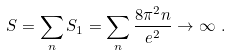<formula> <loc_0><loc_0><loc_500><loc_500>S = \sum _ { n } S _ { 1 } = \sum _ { n } \frac { 8 \pi ^ { 2 } n } { e ^ { 2 } } \to \infty \ .</formula> 